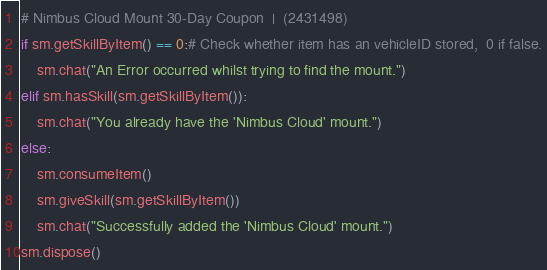<code> <loc_0><loc_0><loc_500><loc_500><_Python_># Nimbus Cloud Mount 30-Day Coupon  |  (2431498)
if sm.getSkillByItem() == 0:# Check whether item has an vehicleID stored,  0 if false.
    sm.chat("An Error occurred whilst trying to find the mount.")
elif sm.hasSkill(sm.getSkillByItem()):
    sm.chat("You already have the 'Nimbus Cloud' mount.")
else:
    sm.consumeItem()
    sm.giveSkill(sm.getSkillByItem())
    sm.chat("Successfully added the 'Nimbus Cloud' mount.")
sm.dispose()
</code> 